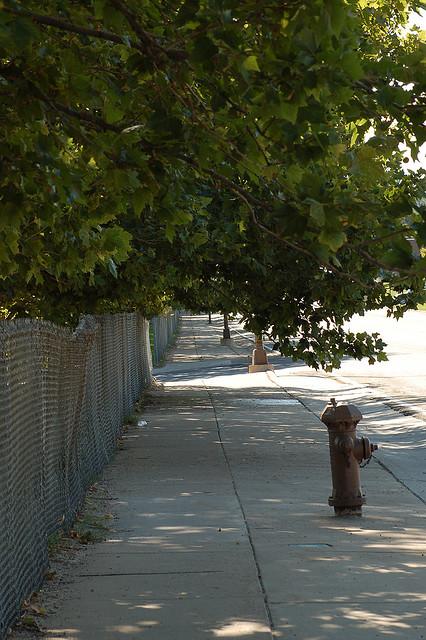What time of day does it appear to be? The long shadows and the warm, soft light suggest it is either early morning or late afternoon, which are typical times for such lighting conditions. 